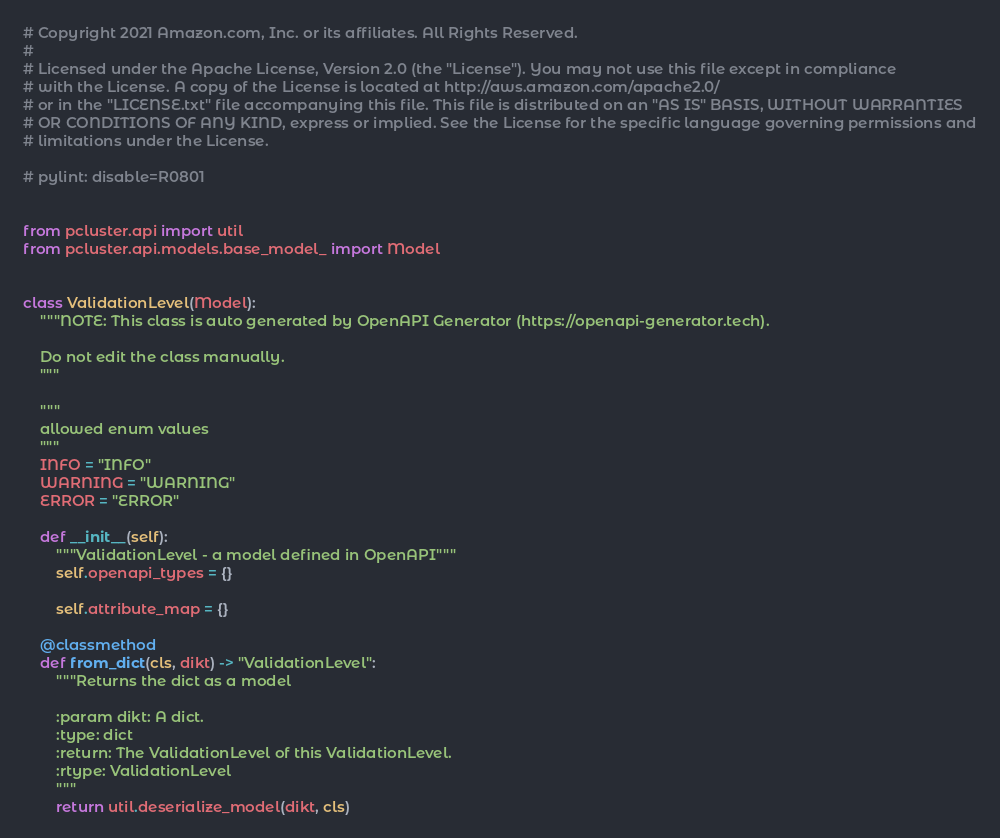Convert code to text. <code><loc_0><loc_0><loc_500><loc_500><_Python_># Copyright 2021 Amazon.com, Inc. or its affiliates. All Rights Reserved.
#
# Licensed under the Apache License, Version 2.0 (the "License"). You may not use this file except in compliance
# with the License. A copy of the License is located at http://aws.amazon.com/apache2.0/
# or in the "LICENSE.txt" file accompanying this file. This file is distributed on an "AS IS" BASIS, WITHOUT WARRANTIES
# OR CONDITIONS OF ANY KIND, express or implied. See the License for the specific language governing permissions and
# limitations under the License.

# pylint: disable=R0801


from pcluster.api import util
from pcluster.api.models.base_model_ import Model


class ValidationLevel(Model):
    """NOTE: This class is auto generated by OpenAPI Generator (https://openapi-generator.tech).

    Do not edit the class manually.
    """

    """
    allowed enum values
    """
    INFO = "INFO"
    WARNING = "WARNING"
    ERROR = "ERROR"

    def __init__(self):
        """ValidationLevel - a model defined in OpenAPI"""
        self.openapi_types = {}

        self.attribute_map = {}

    @classmethod
    def from_dict(cls, dikt) -> "ValidationLevel":
        """Returns the dict as a model

        :param dikt: A dict.
        :type: dict
        :return: The ValidationLevel of this ValidationLevel.
        :rtype: ValidationLevel
        """
        return util.deserialize_model(dikt, cls)
</code> 